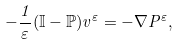Convert formula to latex. <formula><loc_0><loc_0><loc_500><loc_500>- \frac { 1 } { \varepsilon } ( \mathbb { I } - \mathbb { P } ) v ^ { \varepsilon } = - { \nabla P ^ { \varepsilon } } ,</formula> 